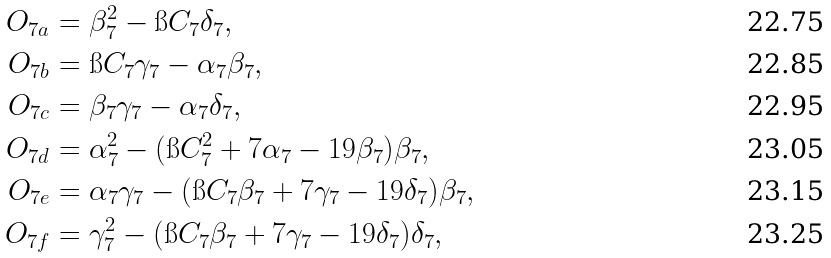<formula> <loc_0><loc_0><loc_500><loc_500>O _ { 7 a } & = \beta _ { 7 } ^ { 2 } - \i C _ { 7 } \delta _ { 7 } , \\ O _ { 7 b } & = \i C _ { 7 } \gamma _ { 7 } - \alpha _ { 7 } \beta _ { 7 } , \\ O _ { 7 c } & = \beta _ { 7 } \gamma _ { 7 } - \alpha _ { 7 } \delta _ { 7 } , \\ O _ { 7 d } & = \alpha _ { 7 } ^ { 2 } - ( \i C _ { 7 } ^ { 2 } + 7 \alpha _ { 7 } - 1 9 \beta _ { 7 } ) \beta _ { 7 } , \\ O _ { 7 e } & = \alpha _ { 7 } \gamma _ { 7 } - ( \i C _ { 7 } \beta _ { 7 } + 7 \gamma _ { 7 } - 1 9 \delta _ { 7 } ) \beta _ { 7 } , \\ O _ { 7 f } & = \gamma _ { 7 } ^ { 2 } - ( \i C _ { 7 } \beta _ { 7 } + 7 \gamma _ { 7 } - 1 9 \delta _ { 7 } ) \delta _ { 7 } ,</formula> 